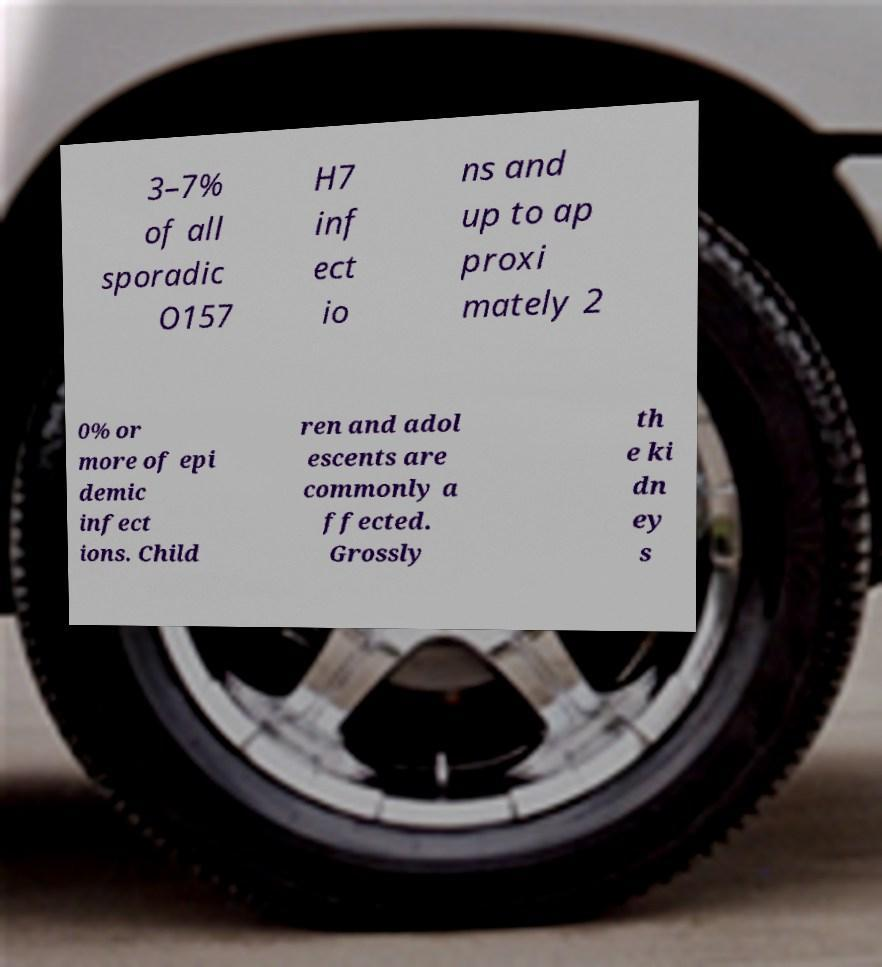Can you accurately transcribe the text from the provided image for me? 3–7% of all sporadic O157 H7 inf ect io ns and up to ap proxi mately 2 0% or more of epi demic infect ions. Child ren and adol escents are commonly a ffected. Grossly th e ki dn ey s 